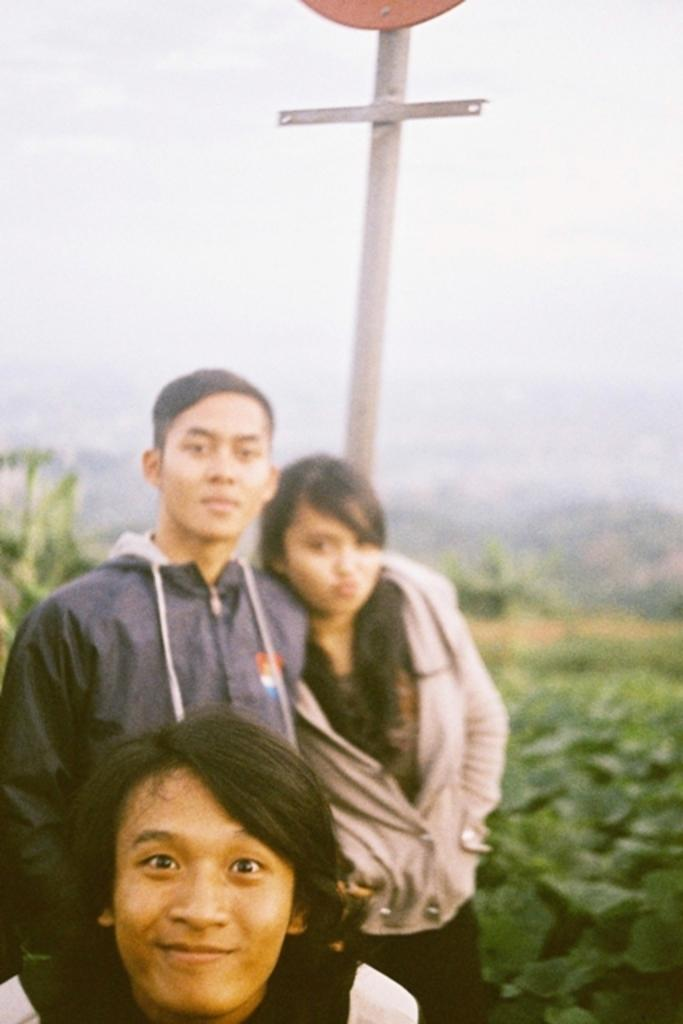How many people are in the image? There are three persons in the image. What can be seen behind the persons? There are plants visible behind the persons, and a pole is also visible. What is visible in the background of the image? The sky is visible in the background of the image. What type of cactus can be seen growing on the pole in the image? There is no cactus visible on the pole in the image. How does the alarm sound in the image? There is no alarm present in the image. 